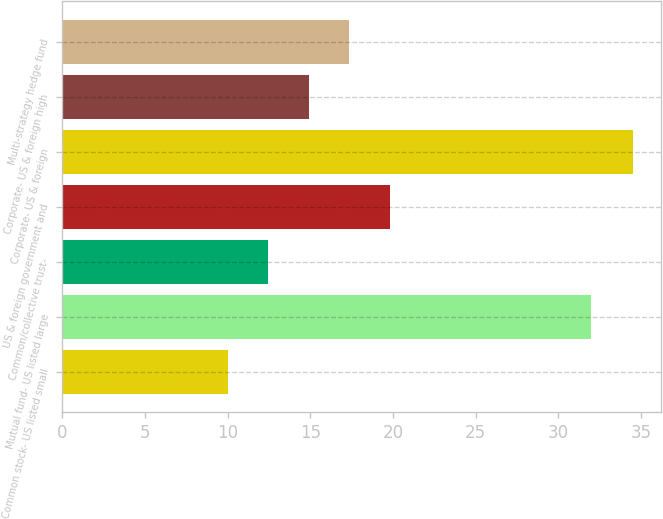Convert chart. <chart><loc_0><loc_0><loc_500><loc_500><bar_chart><fcel>Common stock- US listed small<fcel>Mutual fund- US listed large<fcel>Common/collective trust-<fcel>US & foreign government and<fcel>Corporate- US & foreign<fcel>Corporate- US & foreign high<fcel>Multi-strategy hedge fund<nl><fcel>10<fcel>32<fcel>12.45<fcel>19.8<fcel>34.5<fcel>14.9<fcel>17.35<nl></chart> 